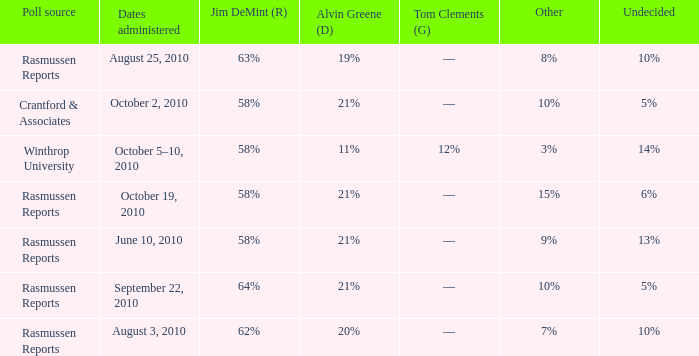Which poll source determined undecided of 5% and Jim DeMint (R) of 58%? Crantford & Associates. 